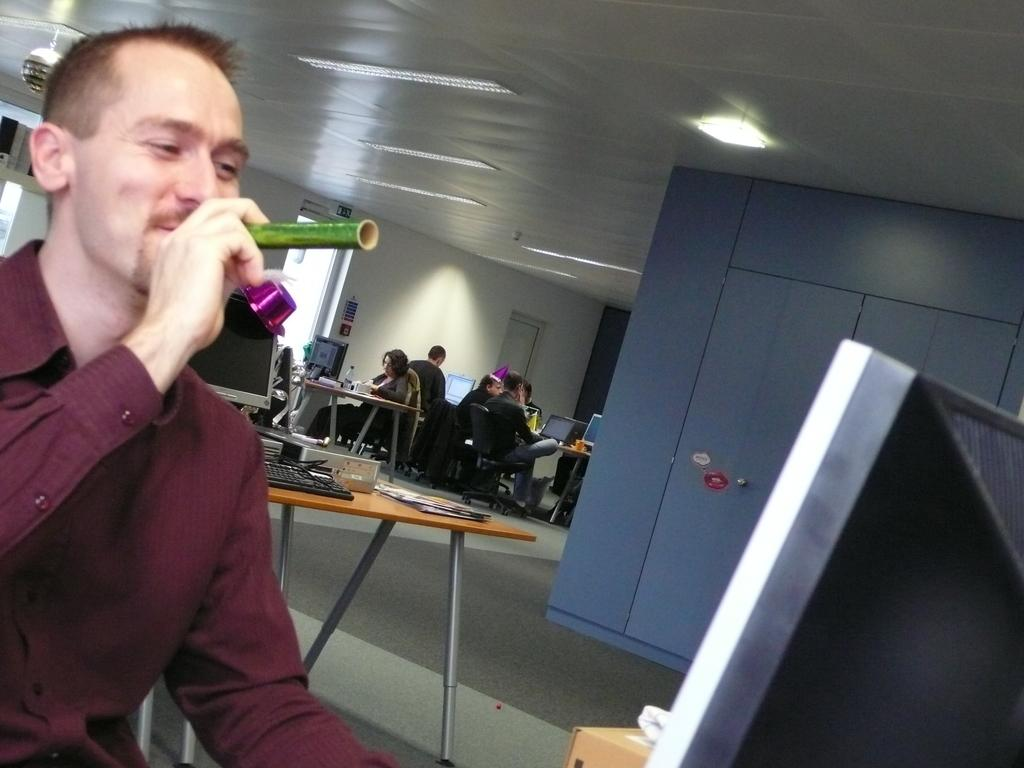Who is the main subject in the image? There is a guy in the image. What is the guy holding in his hand? The guy is holding a green-colored straw in his hand. What can be seen in the background of the image? There are people sitting at tables in the background. What are the objects on top of the tables in the background? Monitors are present on top of the tables in the background. What type of flower is the guy holding in his hand? The guy is not holding a flower in his hand; he is holding a green-colored straw. Can you see any bats flying around in the image? There are no bats visible in the image. 